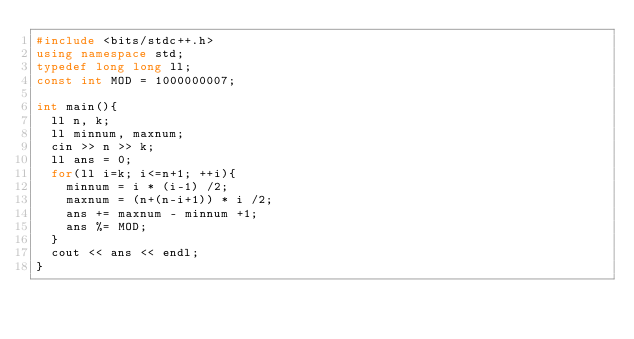<code> <loc_0><loc_0><loc_500><loc_500><_C++_>#include <bits/stdc++.h>
using namespace std;
typedef long long ll;
const int MOD = 1000000007;

int main(){
  ll n, k;
  ll minnum, maxnum;
  cin >> n >> k;
  ll ans = 0;
  for(ll i=k; i<=n+1; ++i){
    minnum = i * (i-1) /2;
    maxnum = (n+(n-i+1)) * i /2;
    ans += maxnum - minnum +1;
    ans %= MOD;
  }
  cout << ans << endl;
}</code> 